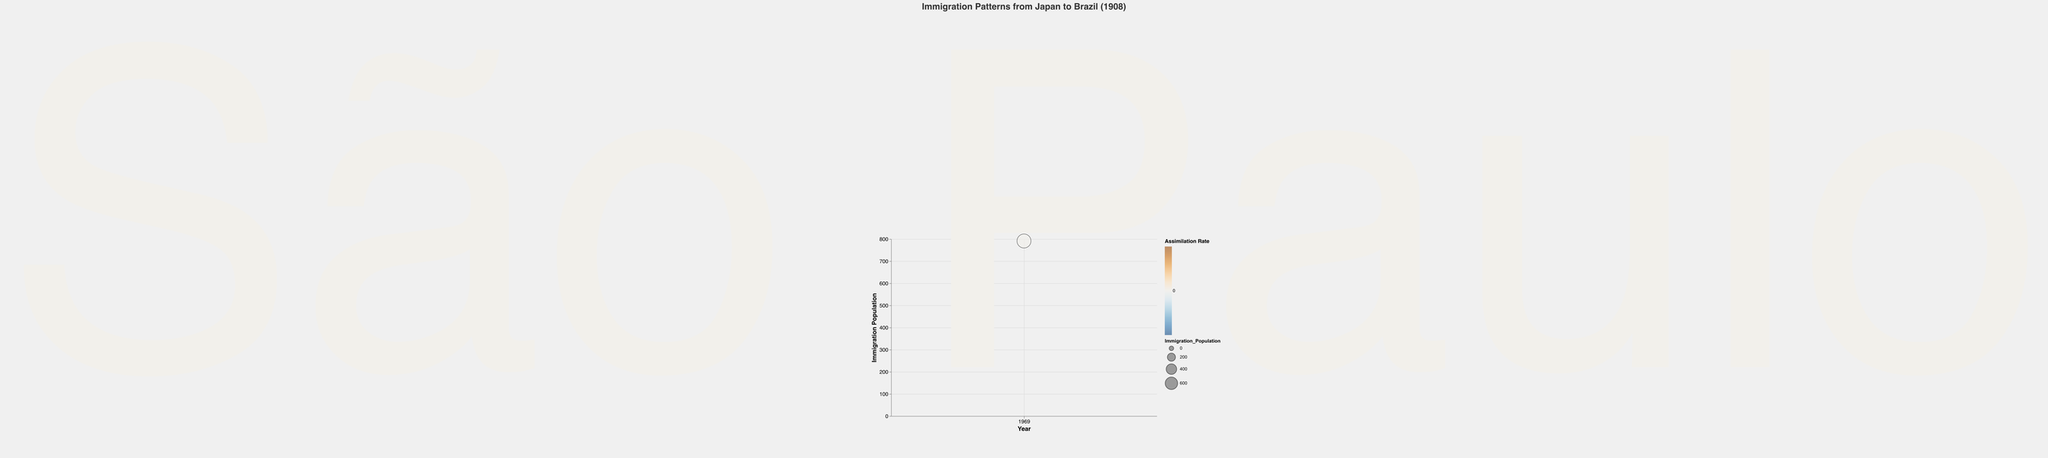What is the title of the chart? The title of the chart is displayed at the top and indicates what the chart is about.
Answer: Immigration Patterns from Japan to Brazil (1908) Which year is represented in the data point? The x-axis represents the year, and it is labeled with just one tick mark for the year 1908.
Answer: 1908 What is the immigration population for the year 1908? The y-axis represents the immigration population, and the single point corresponds to a value of 791.
Answer: 791 What is the assimilation rate for the year 1908? The color of the bubble represents the assimilation rate, which is pointed out in the tooltip when the mouse is over the bubble. The assimilation rate is 10%.
Answer: 0.1 How many cities are noted in the data point for the year 1908? The notable cities are labeled next to the bubble in the figure. São Paulo is the only city mentioned.
Answer: One What is the notable city associated with the immigration population in 1908? This is labeled directly on the bubble in the visualization as São Paulo.
Answer: São Paulo Compare the assimilation rate to the immigration population. Was the assimilation rate high or low relative to the population? The assimilation rate (0.1 or 10%) is relatively low compared to the immigration population of 791, suggesting a significant population with low assimilation.
Answer: Low How would you describe the relationship between the bubble's size and the immigration population? In the bubble chart, the size of the bubble is larger because it scales with the immigration population. The larger bubble size indicates a higher population.
Answer: Larger size indicates larger population If the assimilation rate was higher, how might the color of the bubble be different? The color of the bubble indicates the assimilation rate, transitioning from blue to orange. A higher assimilation rate would likely make the bubble more orange.
Answer: More orange What does the opacity of the bubble convey in the visualization? Opacity of 0.6 makes the bubble somewhat transparent, making it easier to visualize overlapping data in cases of multiple data points in future additions to the chart.
Answer: Transparency for overlap 